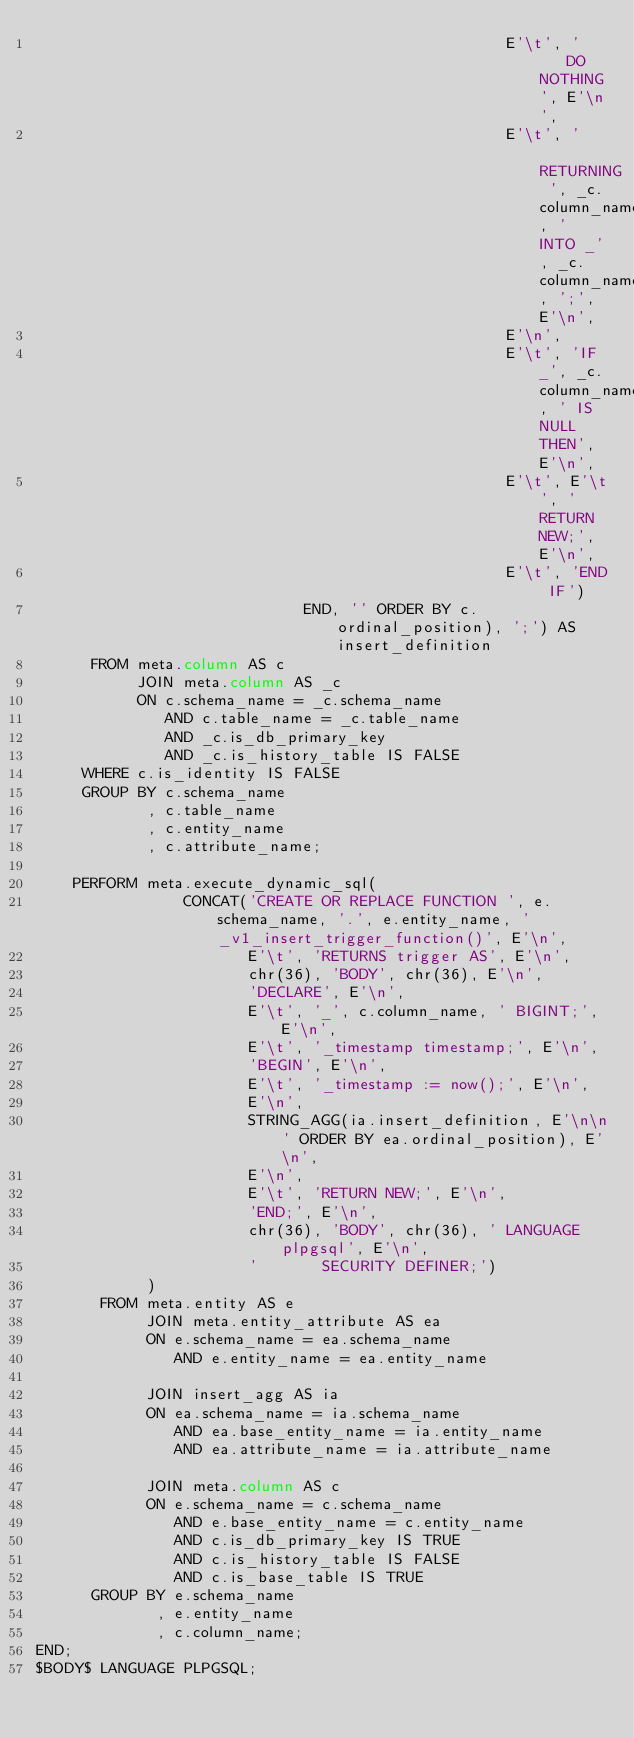Convert code to text. <code><loc_0><loc_0><loc_500><loc_500><_SQL_>                                                   E'\t', '    DO NOTHING', E'\n',
                                                   E'\t', '       RETURNING ', _c.column_name, ' INTO _', _c.column_name, ';', E'\n',
                                                   E'\n',
                                                   E'\t', 'IF _', _c.column_name, ' IS NULL THEN', E'\n',
                                                   E'\t', E'\t', 'RETURN NEW;', E'\n',
                                                   E'\t', 'END IF')
                             END, '' ORDER BY c.ordinal_position), ';') AS insert_definition
      FROM meta.column AS c
           JOIN meta.column AS _c
           ON c.schema_name = _c.schema_name
              AND c.table_name = _c.table_name
              AND _c.is_db_primary_key
              AND _c.is_history_table IS FALSE
     WHERE c.is_identity IS FALSE
     GROUP BY c.schema_name
            , c.table_name
            , c.entity_name
            , c.attribute_name;
    
    PERFORM meta.execute_dynamic_sql(
                CONCAT('CREATE OR REPLACE FUNCTION ', e.schema_name, '.', e.entity_name, '_v1_insert_trigger_function()', E'\n',
                       E'\t', 'RETURNS trigger AS', E'\n',
                       chr(36), 'BODY', chr(36), E'\n',
                       'DECLARE', E'\n',
                       E'\t', '_', c.column_name, ' BIGINT;', E'\n',
                       E'\t', '_timestamp timestamp;', E'\n',
                       'BEGIN', E'\n',
                       E'\t', '_timestamp := now();', E'\n',
                       E'\n',
                       STRING_AGG(ia.insert_definition, E'\n\n' ORDER BY ea.ordinal_position), E'\n',
                       E'\n',
                       E'\t', 'RETURN NEW;', E'\n',
                       'END;', E'\n',
                       chr(36), 'BODY', chr(36), ' LANGUAGE plpgsql', E'\n',
                       '       SECURITY DEFINER;')
            )
       FROM meta.entity AS e
            JOIN meta.entity_attribute AS ea
            ON e.schema_name = ea.schema_name
               AND e.entity_name = ea.entity_name

            JOIN insert_agg AS ia
            ON ea.schema_name = ia.schema_name
               AND ea.base_entity_name = ia.entity_name
               AND ea.attribute_name = ia.attribute_name

            JOIN meta.column AS c
            ON e.schema_name = c.schema_name
               AND e.base_entity_name = c.entity_name
               AND c.is_db_primary_key IS TRUE
               AND c.is_history_table IS FALSE
               AND c.is_base_table IS TRUE
      GROUP BY e.schema_name
             , e.entity_name
             , c.column_name;
END;
$BODY$ LANGUAGE PLPGSQL;</code> 